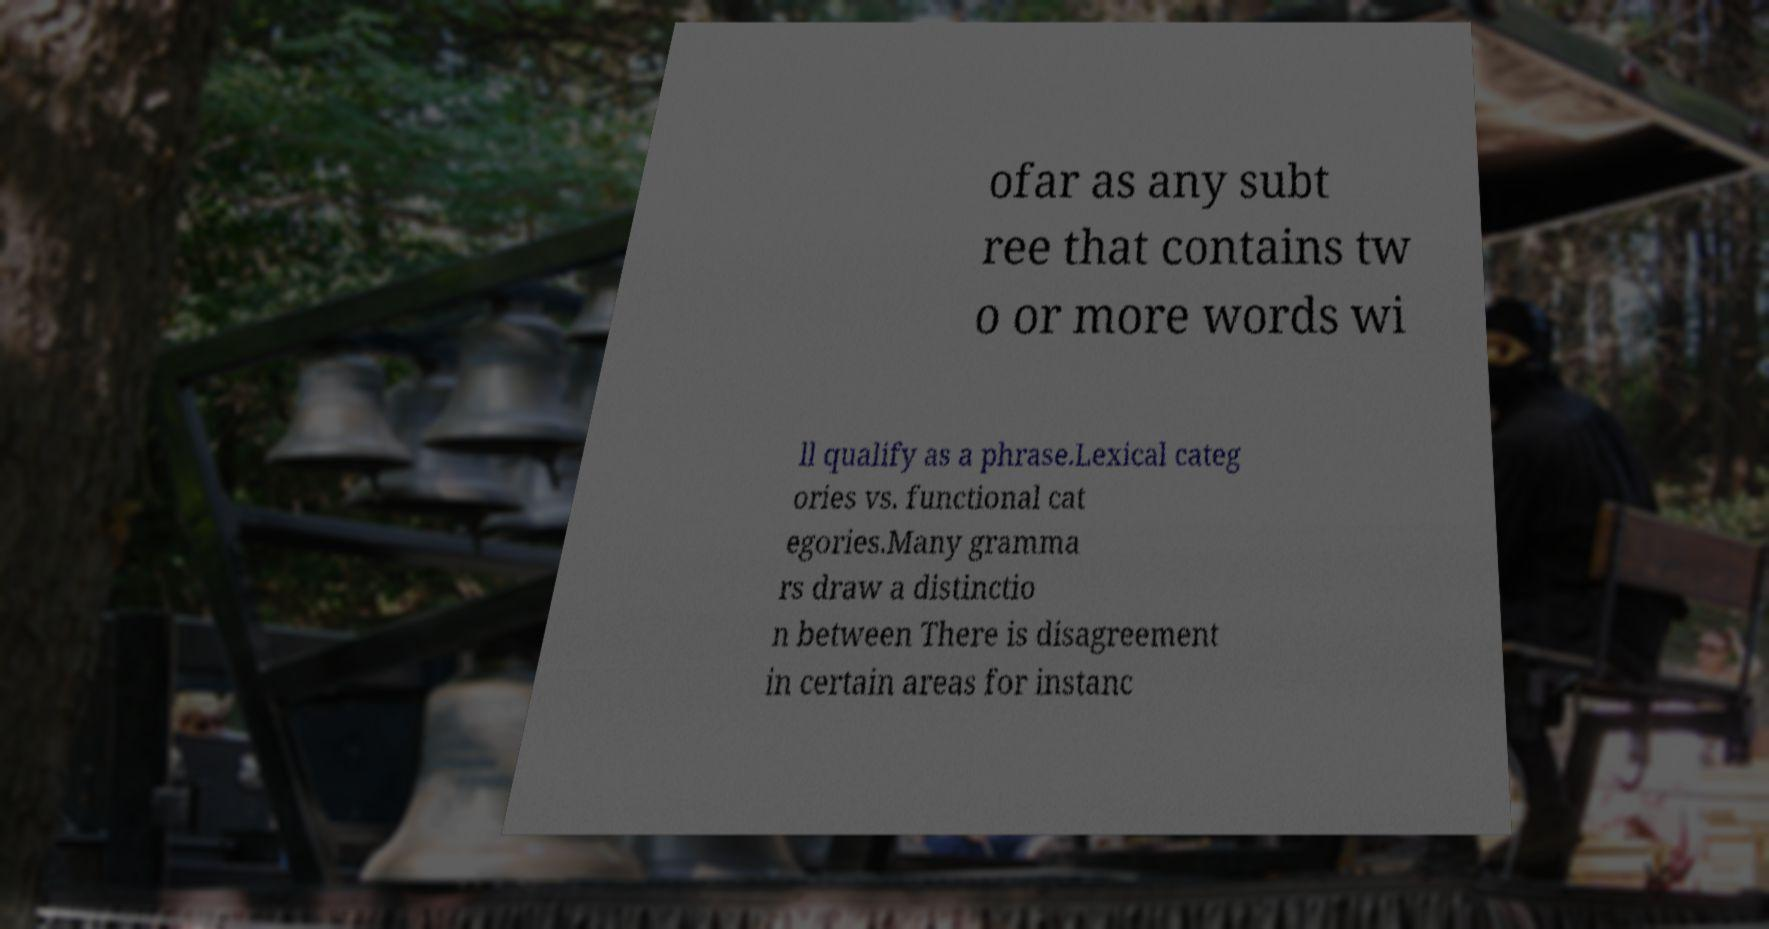Could you assist in decoding the text presented in this image and type it out clearly? ofar as any subt ree that contains tw o or more words wi ll qualify as a phrase.Lexical categ ories vs. functional cat egories.Many gramma rs draw a distinctio n between There is disagreement in certain areas for instanc 